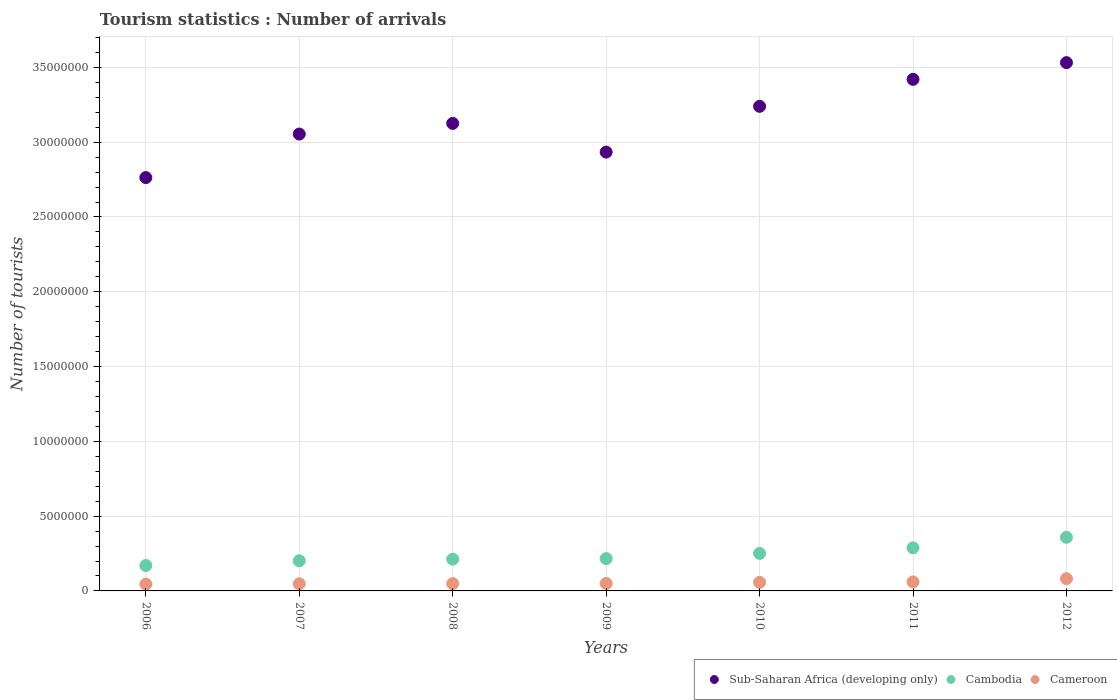How many different coloured dotlines are there?
Offer a terse response. 3. Is the number of dotlines equal to the number of legend labels?
Your answer should be compact. Yes. What is the number of tourist arrivals in Cambodia in 2008?
Your response must be concise. 2.12e+06. Across all years, what is the maximum number of tourist arrivals in Cambodia?
Make the answer very short. 3.58e+06. Across all years, what is the minimum number of tourist arrivals in Cambodia?
Give a very brief answer. 1.70e+06. What is the total number of tourist arrivals in Cameroon in the graph?
Offer a very short reply. 3.91e+06. What is the difference between the number of tourist arrivals in Sub-Saharan Africa (developing only) in 2006 and that in 2011?
Your answer should be very brief. -6.57e+06. What is the difference between the number of tourist arrivals in Cambodia in 2008 and the number of tourist arrivals in Cameroon in 2007?
Give a very brief answer. 1.65e+06. What is the average number of tourist arrivals in Cambodia per year?
Give a very brief answer. 2.43e+06. In the year 2008, what is the difference between the number of tourist arrivals in Sub-Saharan Africa (developing only) and number of tourist arrivals in Cameroon?
Ensure brevity in your answer.  3.08e+07. In how many years, is the number of tourist arrivals in Cambodia greater than 6000000?
Ensure brevity in your answer.  0. What is the ratio of the number of tourist arrivals in Cambodia in 2006 to that in 2012?
Your answer should be very brief. 0.47. What is the difference between the highest and the second highest number of tourist arrivals in Cambodia?
Make the answer very short. 7.02e+05. What is the difference between the highest and the lowest number of tourist arrivals in Sub-Saharan Africa (developing only)?
Offer a very short reply. 7.68e+06. Is the sum of the number of tourist arrivals in Sub-Saharan Africa (developing only) in 2009 and 2012 greater than the maximum number of tourist arrivals in Cambodia across all years?
Ensure brevity in your answer.  Yes. Does the number of tourist arrivals in Cameroon monotonically increase over the years?
Your response must be concise. Yes. Is the number of tourist arrivals in Sub-Saharan Africa (developing only) strictly less than the number of tourist arrivals in Cameroon over the years?
Offer a very short reply. No. How many years are there in the graph?
Ensure brevity in your answer.  7. Are the values on the major ticks of Y-axis written in scientific E-notation?
Keep it short and to the point. No. Where does the legend appear in the graph?
Keep it short and to the point. Bottom right. How many legend labels are there?
Your answer should be very brief. 3. How are the legend labels stacked?
Make the answer very short. Horizontal. What is the title of the graph?
Your response must be concise. Tourism statistics : Number of arrivals. What is the label or title of the Y-axis?
Provide a succinct answer. Number of tourists. What is the Number of tourists in Sub-Saharan Africa (developing only) in 2006?
Provide a short and direct response. 2.76e+07. What is the Number of tourists of Cambodia in 2006?
Provide a short and direct response. 1.70e+06. What is the Number of tourists in Cameroon in 2006?
Provide a succinct answer. 4.51e+05. What is the Number of tourists of Sub-Saharan Africa (developing only) in 2007?
Give a very brief answer. 3.05e+07. What is the Number of tourists in Cambodia in 2007?
Give a very brief answer. 2.02e+06. What is the Number of tourists in Cameroon in 2007?
Keep it short and to the point. 4.77e+05. What is the Number of tourists in Sub-Saharan Africa (developing only) in 2008?
Offer a very short reply. 3.13e+07. What is the Number of tourists of Cambodia in 2008?
Provide a succinct answer. 2.12e+06. What is the Number of tourists in Cameroon in 2008?
Your answer should be compact. 4.87e+05. What is the Number of tourists of Sub-Saharan Africa (developing only) in 2009?
Provide a short and direct response. 2.93e+07. What is the Number of tourists of Cambodia in 2009?
Your answer should be very brief. 2.16e+06. What is the Number of tourists of Cameroon in 2009?
Make the answer very short. 4.98e+05. What is the Number of tourists of Sub-Saharan Africa (developing only) in 2010?
Provide a short and direct response. 3.24e+07. What is the Number of tourists in Cambodia in 2010?
Keep it short and to the point. 2.51e+06. What is the Number of tourists of Cameroon in 2010?
Your answer should be very brief. 5.73e+05. What is the Number of tourists in Sub-Saharan Africa (developing only) in 2011?
Your answer should be compact. 3.42e+07. What is the Number of tourists of Cambodia in 2011?
Ensure brevity in your answer.  2.88e+06. What is the Number of tourists of Cameroon in 2011?
Your response must be concise. 6.04e+05. What is the Number of tourists of Sub-Saharan Africa (developing only) in 2012?
Your answer should be compact. 3.53e+07. What is the Number of tourists of Cambodia in 2012?
Provide a succinct answer. 3.58e+06. What is the Number of tourists in Cameroon in 2012?
Ensure brevity in your answer.  8.17e+05. Across all years, what is the maximum Number of tourists in Sub-Saharan Africa (developing only)?
Your answer should be very brief. 3.53e+07. Across all years, what is the maximum Number of tourists of Cambodia?
Your answer should be very brief. 3.58e+06. Across all years, what is the maximum Number of tourists of Cameroon?
Provide a short and direct response. 8.17e+05. Across all years, what is the minimum Number of tourists of Sub-Saharan Africa (developing only)?
Ensure brevity in your answer.  2.76e+07. Across all years, what is the minimum Number of tourists in Cambodia?
Your answer should be compact. 1.70e+06. Across all years, what is the minimum Number of tourists in Cameroon?
Your answer should be compact. 4.51e+05. What is the total Number of tourists in Sub-Saharan Africa (developing only) in the graph?
Your answer should be very brief. 2.21e+08. What is the total Number of tourists in Cambodia in the graph?
Your answer should be very brief. 1.70e+07. What is the total Number of tourists of Cameroon in the graph?
Your answer should be compact. 3.91e+06. What is the difference between the Number of tourists in Sub-Saharan Africa (developing only) in 2006 and that in 2007?
Offer a very short reply. -2.91e+06. What is the difference between the Number of tourists of Cambodia in 2006 and that in 2007?
Provide a short and direct response. -3.15e+05. What is the difference between the Number of tourists in Cameroon in 2006 and that in 2007?
Provide a short and direct response. -2.60e+04. What is the difference between the Number of tourists in Sub-Saharan Africa (developing only) in 2006 and that in 2008?
Provide a succinct answer. -3.62e+06. What is the difference between the Number of tourists of Cambodia in 2006 and that in 2008?
Your answer should be very brief. -4.25e+05. What is the difference between the Number of tourists in Cameroon in 2006 and that in 2008?
Make the answer very short. -3.60e+04. What is the difference between the Number of tourists of Sub-Saharan Africa (developing only) in 2006 and that in 2009?
Provide a succinct answer. -1.70e+06. What is the difference between the Number of tourists in Cambodia in 2006 and that in 2009?
Provide a short and direct response. -4.62e+05. What is the difference between the Number of tourists in Cameroon in 2006 and that in 2009?
Offer a very short reply. -4.70e+04. What is the difference between the Number of tourists in Sub-Saharan Africa (developing only) in 2006 and that in 2010?
Provide a short and direct response. -4.76e+06. What is the difference between the Number of tourists of Cambodia in 2006 and that in 2010?
Make the answer very short. -8.08e+05. What is the difference between the Number of tourists in Cameroon in 2006 and that in 2010?
Make the answer very short. -1.22e+05. What is the difference between the Number of tourists of Sub-Saharan Africa (developing only) in 2006 and that in 2011?
Your answer should be compact. -6.57e+06. What is the difference between the Number of tourists of Cambodia in 2006 and that in 2011?
Keep it short and to the point. -1.18e+06. What is the difference between the Number of tourists in Cameroon in 2006 and that in 2011?
Your answer should be very brief. -1.53e+05. What is the difference between the Number of tourists in Sub-Saharan Africa (developing only) in 2006 and that in 2012?
Keep it short and to the point. -7.68e+06. What is the difference between the Number of tourists in Cambodia in 2006 and that in 2012?
Your answer should be very brief. -1.88e+06. What is the difference between the Number of tourists of Cameroon in 2006 and that in 2012?
Provide a short and direct response. -3.66e+05. What is the difference between the Number of tourists of Sub-Saharan Africa (developing only) in 2007 and that in 2008?
Your answer should be very brief. -7.12e+05. What is the difference between the Number of tourists in Cameroon in 2007 and that in 2008?
Your answer should be very brief. -10000. What is the difference between the Number of tourists of Sub-Saharan Africa (developing only) in 2007 and that in 2009?
Give a very brief answer. 1.21e+06. What is the difference between the Number of tourists in Cambodia in 2007 and that in 2009?
Provide a succinct answer. -1.47e+05. What is the difference between the Number of tourists of Cameroon in 2007 and that in 2009?
Offer a very short reply. -2.10e+04. What is the difference between the Number of tourists in Sub-Saharan Africa (developing only) in 2007 and that in 2010?
Provide a succinct answer. -1.85e+06. What is the difference between the Number of tourists of Cambodia in 2007 and that in 2010?
Your answer should be compact. -4.93e+05. What is the difference between the Number of tourists of Cameroon in 2007 and that in 2010?
Make the answer very short. -9.60e+04. What is the difference between the Number of tourists of Sub-Saharan Africa (developing only) in 2007 and that in 2011?
Provide a succinct answer. -3.66e+06. What is the difference between the Number of tourists of Cambodia in 2007 and that in 2011?
Your answer should be compact. -8.67e+05. What is the difference between the Number of tourists in Cameroon in 2007 and that in 2011?
Provide a short and direct response. -1.27e+05. What is the difference between the Number of tourists of Sub-Saharan Africa (developing only) in 2007 and that in 2012?
Offer a terse response. -4.77e+06. What is the difference between the Number of tourists in Cambodia in 2007 and that in 2012?
Keep it short and to the point. -1.57e+06. What is the difference between the Number of tourists in Cameroon in 2007 and that in 2012?
Your answer should be very brief. -3.40e+05. What is the difference between the Number of tourists in Sub-Saharan Africa (developing only) in 2008 and that in 2009?
Offer a terse response. 1.92e+06. What is the difference between the Number of tourists of Cambodia in 2008 and that in 2009?
Give a very brief answer. -3.70e+04. What is the difference between the Number of tourists of Cameroon in 2008 and that in 2009?
Your response must be concise. -1.10e+04. What is the difference between the Number of tourists in Sub-Saharan Africa (developing only) in 2008 and that in 2010?
Your answer should be very brief. -1.14e+06. What is the difference between the Number of tourists in Cambodia in 2008 and that in 2010?
Provide a succinct answer. -3.83e+05. What is the difference between the Number of tourists in Cameroon in 2008 and that in 2010?
Make the answer very short. -8.60e+04. What is the difference between the Number of tourists in Sub-Saharan Africa (developing only) in 2008 and that in 2011?
Your answer should be compact. -2.95e+06. What is the difference between the Number of tourists of Cambodia in 2008 and that in 2011?
Your answer should be compact. -7.57e+05. What is the difference between the Number of tourists of Cameroon in 2008 and that in 2011?
Provide a short and direct response. -1.17e+05. What is the difference between the Number of tourists in Sub-Saharan Africa (developing only) in 2008 and that in 2012?
Make the answer very short. -4.06e+06. What is the difference between the Number of tourists in Cambodia in 2008 and that in 2012?
Your answer should be very brief. -1.46e+06. What is the difference between the Number of tourists in Cameroon in 2008 and that in 2012?
Your response must be concise. -3.30e+05. What is the difference between the Number of tourists in Sub-Saharan Africa (developing only) in 2009 and that in 2010?
Ensure brevity in your answer.  -3.06e+06. What is the difference between the Number of tourists in Cambodia in 2009 and that in 2010?
Provide a short and direct response. -3.46e+05. What is the difference between the Number of tourists of Cameroon in 2009 and that in 2010?
Offer a terse response. -7.50e+04. What is the difference between the Number of tourists of Sub-Saharan Africa (developing only) in 2009 and that in 2011?
Ensure brevity in your answer.  -4.86e+06. What is the difference between the Number of tourists of Cambodia in 2009 and that in 2011?
Make the answer very short. -7.20e+05. What is the difference between the Number of tourists in Cameroon in 2009 and that in 2011?
Your response must be concise. -1.06e+05. What is the difference between the Number of tourists of Sub-Saharan Africa (developing only) in 2009 and that in 2012?
Provide a short and direct response. -5.98e+06. What is the difference between the Number of tourists in Cambodia in 2009 and that in 2012?
Make the answer very short. -1.42e+06. What is the difference between the Number of tourists in Cameroon in 2009 and that in 2012?
Give a very brief answer. -3.19e+05. What is the difference between the Number of tourists of Sub-Saharan Africa (developing only) in 2010 and that in 2011?
Your answer should be compact. -1.81e+06. What is the difference between the Number of tourists of Cambodia in 2010 and that in 2011?
Give a very brief answer. -3.74e+05. What is the difference between the Number of tourists of Cameroon in 2010 and that in 2011?
Offer a very short reply. -3.10e+04. What is the difference between the Number of tourists of Sub-Saharan Africa (developing only) in 2010 and that in 2012?
Offer a terse response. -2.92e+06. What is the difference between the Number of tourists of Cambodia in 2010 and that in 2012?
Your answer should be very brief. -1.08e+06. What is the difference between the Number of tourists of Cameroon in 2010 and that in 2012?
Offer a very short reply. -2.44e+05. What is the difference between the Number of tourists of Sub-Saharan Africa (developing only) in 2011 and that in 2012?
Offer a very short reply. -1.12e+06. What is the difference between the Number of tourists in Cambodia in 2011 and that in 2012?
Your response must be concise. -7.02e+05. What is the difference between the Number of tourists of Cameroon in 2011 and that in 2012?
Offer a very short reply. -2.13e+05. What is the difference between the Number of tourists in Sub-Saharan Africa (developing only) in 2006 and the Number of tourists in Cambodia in 2007?
Your answer should be very brief. 2.56e+07. What is the difference between the Number of tourists in Sub-Saharan Africa (developing only) in 2006 and the Number of tourists in Cameroon in 2007?
Make the answer very short. 2.72e+07. What is the difference between the Number of tourists of Cambodia in 2006 and the Number of tourists of Cameroon in 2007?
Make the answer very short. 1.22e+06. What is the difference between the Number of tourists of Sub-Saharan Africa (developing only) in 2006 and the Number of tourists of Cambodia in 2008?
Make the answer very short. 2.55e+07. What is the difference between the Number of tourists in Sub-Saharan Africa (developing only) in 2006 and the Number of tourists in Cameroon in 2008?
Ensure brevity in your answer.  2.71e+07. What is the difference between the Number of tourists of Cambodia in 2006 and the Number of tourists of Cameroon in 2008?
Offer a terse response. 1.21e+06. What is the difference between the Number of tourists in Sub-Saharan Africa (developing only) in 2006 and the Number of tourists in Cambodia in 2009?
Your response must be concise. 2.55e+07. What is the difference between the Number of tourists in Sub-Saharan Africa (developing only) in 2006 and the Number of tourists in Cameroon in 2009?
Offer a very short reply. 2.71e+07. What is the difference between the Number of tourists in Cambodia in 2006 and the Number of tourists in Cameroon in 2009?
Ensure brevity in your answer.  1.20e+06. What is the difference between the Number of tourists of Sub-Saharan Africa (developing only) in 2006 and the Number of tourists of Cambodia in 2010?
Your answer should be very brief. 2.51e+07. What is the difference between the Number of tourists of Sub-Saharan Africa (developing only) in 2006 and the Number of tourists of Cameroon in 2010?
Your answer should be compact. 2.71e+07. What is the difference between the Number of tourists of Cambodia in 2006 and the Number of tourists of Cameroon in 2010?
Provide a succinct answer. 1.13e+06. What is the difference between the Number of tourists of Sub-Saharan Africa (developing only) in 2006 and the Number of tourists of Cambodia in 2011?
Your response must be concise. 2.48e+07. What is the difference between the Number of tourists of Sub-Saharan Africa (developing only) in 2006 and the Number of tourists of Cameroon in 2011?
Make the answer very short. 2.70e+07. What is the difference between the Number of tourists in Cambodia in 2006 and the Number of tourists in Cameroon in 2011?
Your answer should be very brief. 1.10e+06. What is the difference between the Number of tourists of Sub-Saharan Africa (developing only) in 2006 and the Number of tourists of Cambodia in 2012?
Your answer should be compact. 2.40e+07. What is the difference between the Number of tourists in Sub-Saharan Africa (developing only) in 2006 and the Number of tourists in Cameroon in 2012?
Offer a terse response. 2.68e+07. What is the difference between the Number of tourists in Cambodia in 2006 and the Number of tourists in Cameroon in 2012?
Your response must be concise. 8.83e+05. What is the difference between the Number of tourists of Sub-Saharan Africa (developing only) in 2007 and the Number of tourists of Cambodia in 2008?
Your answer should be compact. 2.84e+07. What is the difference between the Number of tourists of Sub-Saharan Africa (developing only) in 2007 and the Number of tourists of Cameroon in 2008?
Your answer should be very brief. 3.01e+07. What is the difference between the Number of tourists of Cambodia in 2007 and the Number of tourists of Cameroon in 2008?
Keep it short and to the point. 1.53e+06. What is the difference between the Number of tourists in Sub-Saharan Africa (developing only) in 2007 and the Number of tourists in Cambodia in 2009?
Ensure brevity in your answer.  2.84e+07. What is the difference between the Number of tourists of Sub-Saharan Africa (developing only) in 2007 and the Number of tourists of Cameroon in 2009?
Offer a terse response. 3.00e+07. What is the difference between the Number of tourists of Cambodia in 2007 and the Number of tourists of Cameroon in 2009?
Your answer should be compact. 1.52e+06. What is the difference between the Number of tourists in Sub-Saharan Africa (developing only) in 2007 and the Number of tourists in Cambodia in 2010?
Give a very brief answer. 2.80e+07. What is the difference between the Number of tourists of Sub-Saharan Africa (developing only) in 2007 and the Number of tourists of Cameroon in 2010?
Offer a very short reply. 3.00e+07. What is the difference between the Number of tourists of Cambodia in 2007 and the Number of tourists of Cameroon in 2010?
Offer a very short reply. 1.44e+06. What is the difference between the Number of tourists in Sub-Saharan Africa (developing only) in 2007 and the Number of tourists in Cambodia in 2011?
Give a very brief answer. 2.77e+07. What is the difference between the Number of tourists in Sub-Saharan Africa (developing only) in 2007 and the Number of tourists in Cameroon in 2011?
Offer a terse response. 2.99e+07. What is the difference between the Number of tourists of Cambodia in 2007 and the Number of tourists of Cameroon in 2011?
Make the answer very short. 1.41e+06. What is the difference between the Number of tourists in Sub-Saharan Africa (developing only) in 2007 and the Number of tourists in Cambodia in 2012?
Keep it short and to the point. 2.70e+07. What is the difference between the Number of tourists in Sub-Saharan Africa (developing only) in 2007 and the Number of tourists in Cameroon in 2012?
Your answer should be very brief. 2.97e+07. What is the difference between the Number of tourists in Cambodia in 2007 and the Number of tourists in Cameroon in 2012?
Offer a very short reply. 1.20e+06. What is the difference between the Number of tourists in Sub-Saharan Africa (developing only) in 2008 and the Number of tourists in Cambodia in 2009?
Your answer should be very brief. 2.91e+07. What is the difference between the Number of tourists of Sub-Saharan Africa (developing only) in 2008 and the Number of tourists of Cameroon in 2009?
Your answer should be very brief. 3.08e+07. What is the difference between the Number of tourists in Cambodia in 2008 and the Number of tourists in Cameroon in 2009?
Give a very brief answer. 1.63e+06. What is the difference between the Number of tourists in Sub-Saharan Africa (developing only) in 2008 and the Number of tourists in Cambodia in 2010?
Your answer should be very brief. 2.87e+07. What is the difference between the Number of tourists in Sub-Saharan Africa (developing only) in 2008 and the Number of tourists in Cameroon in 2010?
Your answer should be very brief. 3.07e+07. What is the difference between the Number of tourists in Cambodia in 2008 and the Number of tourists in Cameroon in 2010?
Give a very brief answer. 1.55e+06. What is the difference between the Number of tourists of Sub-Saharan Africa (developing only) in 2008 and the Number of tourists of Cambodia in 2011?
Provide a short and direct response. 2.84e+07. What is the difference between the Number of tourists in Sub-Saharan Africa (developing only) in 2008 and the Number of tourists in Cameroon in 2011?
Ensure brevity in your answer.  3.07e+07. What is the difference between the Number of tourists of Cambodia in 2008 and the Number of tourists of Cameroon in 2011?
Offer a terse response. 1.52e+06. What is the difference between the Number of tourists of Sub-Saharan Africa (developing only) in 2008 and the Number of tourists of Cambodia in 2012?
Ensure brevity in your answer.  2.77e+07. What is the difference between the Number of tourists in Sub-Saharan Africa (developing only) in 2008 and the Number of tourists in Cameroon in 2012?
Provide a succinct answer. 3.04e+07. What is the difference between the Number of tourists of Cambodia in 2008 and the Number of tourists of Cameroon in 2012?
Ensure brevity in your answer.  1.31e+06. What is the difference between the Number of tourists of Sub-Saharan Africa (developing only) in 2009 and the Number of tourists of Cambodia in 2010?
Ensure brevity in your answer.  2.68e+07. What is the difference between the Number of tourists in Sub-Saharan Africa (developing only) in 2009 and the Number of tourists in Cameroon in 2010?
Provide a short and direct response. 2.88e+07. What is the difference between the Number of tourists in Cambodia in 2009 and the Number of tourists in Cameroon in 2010?
Ensure brevity in your answer.  1.59e+06. What is the difference between the Number of tourists in Sub-Saharan Africa (developing only) in 2009 and the Number of tourists in Cambodia in 2011?
Your answer should be very brief. 2.65e+07. What is the difference between the Number of tourists in Sub-Saharan Africa (developing only) in 2009 and the Number of tourists in Cameroon in 2011?
Keep it short and to the point. 2.87e+07. What is the difference between the Number of tourists in Cambodia in 2009 and the Number of tourists in Cameroon in 2011?
Ensure brevity in your answer.  1.56e+06. What is the difference between the Number of tourists of Sub-Saharan Africa (developing only) in 2009 and the Number of tourists of Cambodia in 2012?
Offer a very short reply. 2.58e+07. What is the difference between the Number of tourists in Sub-Saharan Africa (developing only) in 2009 and the Number of tourists in Cameroon in 2012?
Provide a succinct answer. 2.85e+07. What is the difference between the Number of tourists of Cambodia in 2009 and the Number of tourists of Cameroon in 2012?
Provide a short and direct response. 1.34e+06. What is the difference between the Number of tourists of Sub-Saharan Africa (developing only) in 2010 and the Number of tourists of Cambodia in 2011?
Make the answer very short. 2.95e+07. What is the difference between the Number of tourists of Sub-Saharan Africa (developing only) in 2010 and the Number of tourists of Cameroon in 2011?
Offer a very short reply. 3.18e+07. What is the difference between the Number of tourists in Cambodia in 2010 and the Number of tourists in Cameroon in 2011?
Keep it short and to the point. 1.90e+06. What is the difference between the Number of tourists in Sub-Saharan Africa (developing only) in 2010 and the Number of tourists in Cambodia in 2012?
Your answer should be very brief. 2.88e+07. What is the difference between the Number of tourists in Sub-Saharan Africa (developing only) in 2010 and the Number of tourists in Cameroon in 2012?
Provide a short and direct response. 3.16e+07. What is the difference between the Number of tourists of Cambodia in 2010 and the Number of tourists of Cameroon in 2012?
Give a very brief answer. 1.69e+06. What is the difference between the Number of tourists of Sub-Saharan Africa (developing only) in 2011 and the Number of tourists of Cambodia in 2012?
Provide a succinct answer. 3.06e+07. What is the difference between the Number of tourists of Sub-Saharan Africa (developing only) in 2011 and the Number of tourists of Cameroon in 2012?
Ensure brevity in your answer.  3.34e+07. What is the difference between the Number of tourists in Cambodia in 2011 and the Number of tourists in Cameroon in 2012?
Your response must be concise. 2.06e+06. What is the average Number of tourists of Sub-Saharan Africa (developing only) per year?
Your answer should be compact. 3.15e+07. What is the average Number of tourists of Cambodia per year?
Provide a succinct answer. 2.43e+06. What is the average Number of tourists in Cameroon per year?
Offer a very short reply. 5.58e+05. In the year 2006, what is the difference between the Number of tourists of Sub-Saharan Africa (developing only) and Number of tourists of Cambodia?
Your answer should be compact. 2.59e+07. In the year 2006, what is the difference between the Number of tourists in Sub-Saharan Africa (developing only) and Number of tourists in Cameroon?
Keep it short and to the point. 2.72e+07. In the year 2006, what is the difference between the Number of tourists of Cambodia and Number of tourists of Cameroon?
Give a very brief answer. 1.25e+06. In the year 2007, what is the difference between the Number of tourists of Sub-Saharan Africa (developing only) and Number of tourists of Cambodia?
Your answer should be compact. 2.85e+07. In the year 2007, what is the difference between the Number of tourists in Sub-Saharan Africa (developing only) and Number of tourists in Cameroon?
Give a very brief answer. 3.01e+07. In the year 2007, what is the difference between the Number of tourists of Cambodia and Number of tourists of Cameroon?
Give a very brief answer. 1.54e+06. In the year 2008, what is the difference between the Number of tourists in Sub-Saharan Africa (developing only) and Number of tourists in Cambodia?
Your answer should be compact. 2.91e+07. In the year 2008, what is the difference between the Number of tourists of Sub-Saharan Africa (developing only) and Number of tourists of Cameroon?
Provide a succinct answer. 3.08e+07. In the year 2008, what is the difference between the Number of tourists of Cambodia and Number of tourists of Cameroon?
Your answer should be very brief. 1.64e+06. In the year 2009, what is the difference between the Number of tourists in Sub-Saharan Africa (developing only) and Number of tourists in Cambodia?
Give a very brief answer. 2.72e+07. In the year 2009, what is the difference between the Number of tourists of Sub-Saharan Africa (developing only) and Number of tourists of Cameroon?
Your answer should be compact. 2.88e+07. In the year 2009, what is the difference between the Number of tourists of Cambodia and Number of tourists of Cameroon?
Provide a succinct answer. 1.66e+06. In the year 2010, what is the difference between the Number of tourists of Sub-Saharan Africa (developing only) and Number of tourists of Cambodia?
Offer a very short reply. 2.99e+07. In the year 2010, what is the difference between the Number of tourists of Sub-Saharan Africa (developing only) and Number of tourists of Cameroon?
Give a very brief answer. 3.18e+07. In the year 2010, what is the difference between the Number of tourists of Cambodia and Number of tourists of Cameroon?
Make the answer very short. 1.94e+06. In the year 2011, what is the difference between the Number of tourists of Sub-Saharan Africa (developing only) and Number of tourists of Cambodia?
Provide a succinct answer. 3.13e+07. In the year 2011, what is the difference between the Number of tourists in Sub-Saharan Africa (developing only) and Number of tourists in Cameroon?
Offer a terse response. 3.36e+07. In the year 2011, what is the difference between the Number of tourists of Cambodia and Number of tourists of Cameroon?
Provide a succinct answer. 2.28e+06. In the year 2012, what is the difference between the Number of tourists in Sub-Saharan Africa (developing only) and Number of tourists in Cambodia?
Keep it short and to the point. 3.17e+07. In the year 2012, what is the difference between the Number of tourists in Sub-Saharan Africa (developing only) and Number of tourists in Cameroon?
Keep it short and to the point. 3.45e+07. In the year 2012, what is the difference between the Number of tourists of Cambodia and Number of tourists of Cameroon?
Make the answer very short. 2.77e+06. What is the ratio of the Number of tourists in Sub-Saharan Africa (developing only) in 2006 to that in 2007?
Your answer should be very brief. 0.9. What is the ratio of the Number of tourists of Cambodia in 2006 to that in 2007?
Offer a terse response. 0.84. What is the ratio of the Number of tourists of Cameroon in 2006 to that in 2007?
Your answer should be compact. 0.95. What is the ratio of the Number of tourists in Sub-Saharan Africa (developing only) in 2006 to that in 2008?
Your answer should be compact. 0.88. What is the ratio of the Number of tourists in Cambodia in 2006 to that in 2008?
Your response must be concise. 0.8. What is the ratio of the Number of tourists of Cameroon in 2006 to that in 2008?
Provide a short and direct response. 0.93. What is the ratio of the Number of tourists of Sub-Saharan Africa (developing only) in 2006 to that in 2009?
Your answer should be compact. 0.94. What is the ratio of the Number of tourists in Cambodia in 2006 to that in 2009?
Give a very brief answer. 0.79. What is the ratio of the Number of tourists in Cameroon in 2006 to that in 2009?
Your answer should be very brief. 0.91. What is the ratio of the Number of tourists in Sub-Saharan Africa (developing only) in 2006 to that in 2010?
Keep it short and to the point. 0.85. What is the ratio of the Number of tourists in Cambodia in 2006 to that in 2010?
Give a very brief answer. 0.68. What is the ratio of the Number of tourists in Cameroon in 2006 to that in 2010?
Your answer should be very brief. 0.79. What is the ratio of the Number of tourists in Sub-Saharan Africa (developing only) in 2006 to that in 2011?
Offer a terse response. 0.81. What is the ratio of the Number of tourists in Cambodia in 2006 to that in 2011?
Your answer should be very brief. 0.59. What is the ratio of the Number of tourists in Cameroon in 2006 to that in 2011?
Your answer should be compact. 0.75. What is the ratio of the Number of tourists of Sub-Saharan Africa (developing only) in 2006 to that in 2012?
Offer a terse response. 0.78. What is the ratio of the Number of tourists in Cambodia in 2006 to that in 2012?
Your answer should be compact. 0.47. What is the ratio of the Number of tourists in Cameroon in 2006 to that in 2012?
Offer a terse response. 0.55. What is the ratio of the Number of tourists in Sub-Saharan Africa (developing only) in 2007 to that in 2008?
Offer a very short reply. 0.98. What is the ratio of the Number of tourists in Cambodia in 2007 to that in 2008?
Offer a terse response. 0.95. What is the ratio of the Number of tourists of Cameroon in 2007 to that in 2008?
Provide a succinct answer. 0.98. What is the ratio of the Number of tourists of Sub-Saharan Africa (developing only) in 2007 to that in 2009?
Give a very brief answer. 1.04. What is the ratio of the Number of tourists in Cambodia in 2007 to that in 2009?
Provide a short and direct response. 0.93. What is the ratio of the Number of tourists of Cameroon in 2007 to that in 2009?
Keep it short and to the point. 0.96. What is the ratio of the Number of tourists of Sub-Saharan Africa (developing only) in 2007 to that in 2010?
Your response must be concise. 0.94. What is the ratio of the Number of tourists of Cambodia in 2007 to that in 2010?
Keep it short and to the point. 0.8. What is the ratio of the Number of tourists of Cameroon in 2007 to that in 2010?
Offer a terse response. 0.83. What is the ratio of the Number of tourists in Sub-Saharan Africa (developing only) in 2007 to that in 2011?
Keep it short and to the point. 0.89. What is the ratio of the Number of tourists in Cambodia in 2007 to that in 2011?
Offer a very short reply. 0.7. What is the ratio of the Number of tourists of Cameroon in 2007 to that in 2011?
Offer a very short reply. 0.79. What is the ratio of the Number of tourists of Sub-Saharan Africa (developing only) in 2007 to that in 2012?
Your response must be concise. 0.86. What is the ratio of the Number of tourists of Cambodia in 2007 to that in 2012?
Your answer should be compact. 0.56. What is the ratio of the Number of tourists in Cameroon in 2007 to that in 2012?
Give a very brief answer. 0.58. What is the ratio of the Number of tourists of Sub-Saharan Africa (developing only) in 2008 to that in 2009?
Keep it short and to the point. 1.07. What is the ratio of the Number of tourists in Cambodia in 2008 to that in 2009?
Offer a terse response. 0.98. What is the ratio of the Number of tourists in Cameroon in 2008 to that in 2009?
Offer a very short reply. 0.98. What is the ratio of the Number of tourists of Sub-Saharan Africa (developing only) in 2008 to that in 2010?
Make the answer very short. 0.96. What is the ratio of the Number of tourists of Cambodia in 2008 to that in 2010?
Your response must be concise. 0.85. What is the ratio of the Number of tourists in Cameroon in 2008 to that in 2010?
Provide a succinct answer. 0.85. What is the ratio of the Number of tourists in Sub-Saharan Africa (developing only) in 2008 to that in 2011?
Your response must be concise. 0.91. What is the ratio of the Number of tourists in Cambodia in 2008 to that in 2011?
Give a very brief answer. 0.74. What is the ratio of the Number of tourists in Cameroon in 2008 to that in 2011?
Ensure brevity in your answer.  0.81. What is the ratio of the Number of tourists of Sub-Saharan Africa (developing only) in 2008 to that in 2012?
Your response must be concise. 0.89. What is the ratio of the Number of tourists of Cambodia in 2008 to that in 2012?
Your answer should be very brief. 0.59. What is the ratio of the Number of tourists in Cameroon in 2008 to that in 2012?
Make the answer very short. 0.6. What is the ratio of the Number of tourists in Sub-Saharan Africa (developing only) in 2009 to that in 2010?
Offer a terse response. 0.91. What is the ratio of the Number of tourists of Cambodia in 2009 to that in 2010?
Make the answer very short. 0.86. What is the ratio of the Number of tourists in Cameroon in 2009 to that in 2010?
Provide a short and direct response. 0.87. What is the ratio of the Number of tourists in Sub-Saharan Africa (developing only) in 2009 to that in 2011?
Make the answer very short. 0.86. What is the ratio of the Number of tourists in Cambodia in 2009 to that in 2011?
Offer a terse response. 0.75. What is the ratio of the Number of tourists of Cameroon in 2009 to that in 2011?
Offer a terse response. 0.82. What is the ratio of the Number of tourists in Sub-Saharan Africa (developing only) in 2009 to that in 2012?
Provide a succinct answer. 0.83. What is the ratio of the Number of tourists in Cambodia in 2009 to that in 2012?
Your answer should be very brief. 0.6. What is the ratio of the Number of tourists in Cameroon in 2009 to that in 2012?
Your answer should be compact. 0.61. What is the ratio of the Number of tourists of Sub-Saharan Africa (developing only) in 2010 to that in 2011?
Provide a short and direct response. 0.95. What is the ratio of the Number of tourists of Cambodia in 2010 to that in 2011?
Ensure brevity in your answer.  0.87. What is the ratio of the Number of tourists of Cameroon in 2010 to that in 2011?
Provide a succinct answer. 0.95. What is the ratio of the Number of tourists in Sub-Saharan Africa (developing only) in 2010 to that in 2012?
Provide a succinct answer. 0.92. What is the ratio of the Number of tourists in Cambodia in 2010 to that in 2012?
Provide a succinct answer. 0.7. What is the ratio of the Number of tourists of Cameroon in 2010 to that in 2012?
Provide a succinct answer. 0.7. What is the ratio of the Number of tourists of Sub-Saharan Africa (developing only) in 2011 to that in 2012?
Your answer should be compact. 0.97. What is the ratio of the Number of tourists of Cambodia in 2011 to that in 2012?
Your response must be concise. 0.8. What is the ratio of the Number of tourists in Cameroon in 2011 to that in 2012?
Give a very brief answer. 0.74. What is the difference between the highest and the second highest Number of tourists of Sub-Saharan Africa (developing only)?
Ensure brevity in your answer.  1.12e+06. What is the difference between the highest and the second highest Number of tourists of Cambodia?
Make the answer very short. 7.02e+05. What is the difference between the highest and the second highest Number of tourists in Cameroon?
Make the answer very short. 2.13e+05. What is the difference between the highest and the lowest Number of tourists in Sub-Saharan Africa (developing only)?
Offer a very short reply. 7.68e+06. What is the difference between the highest and the lowest Number of tourists in Cambodia?
Offer a terse response. 1.88e+06. What is the difference between the highest and the lowest Number of tourists of Cameroon?
Make the answer very short. 3.66e+05. 